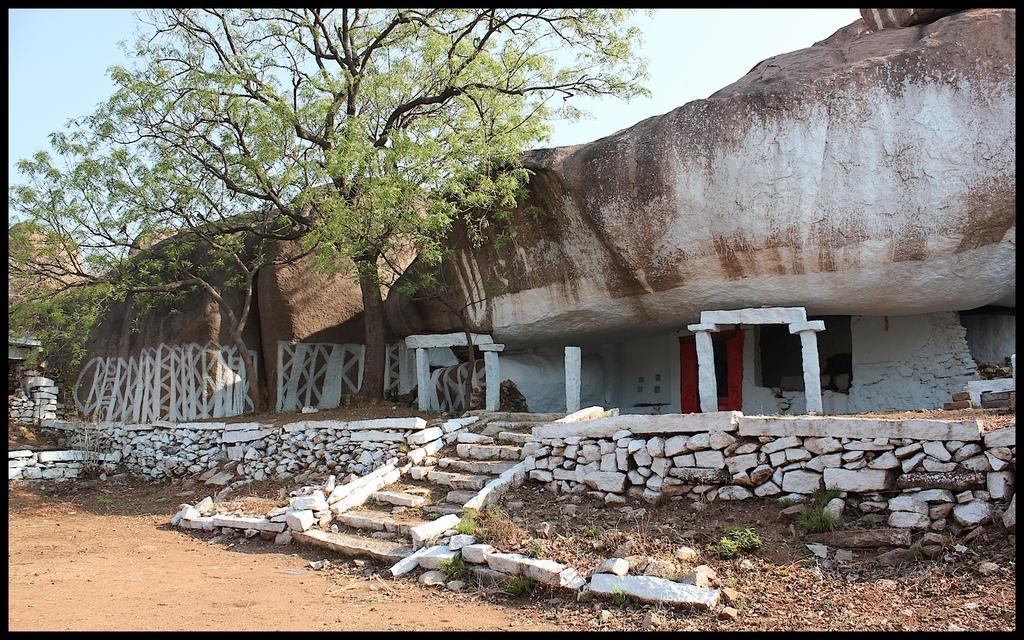Could you give a brief overview of what you see in this image? In the image we can see these are the stairs, stones, rocks, tree, sand and a sky. 